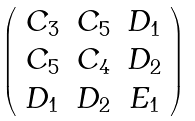Convert formula to latex. <formula><loc_0><loc_0><loc_500><loc_500>\left ( \begin{array} { c c c } C _ { 3 } & C _ { 5 } & D _ { 1 } \\ C _ { 5 } & C _ { 4 } & D _ { 2 } \\ D _ { 1 } & D _ { 2 } & E _ { 1 } \\ \end{array} \right )</formula> 